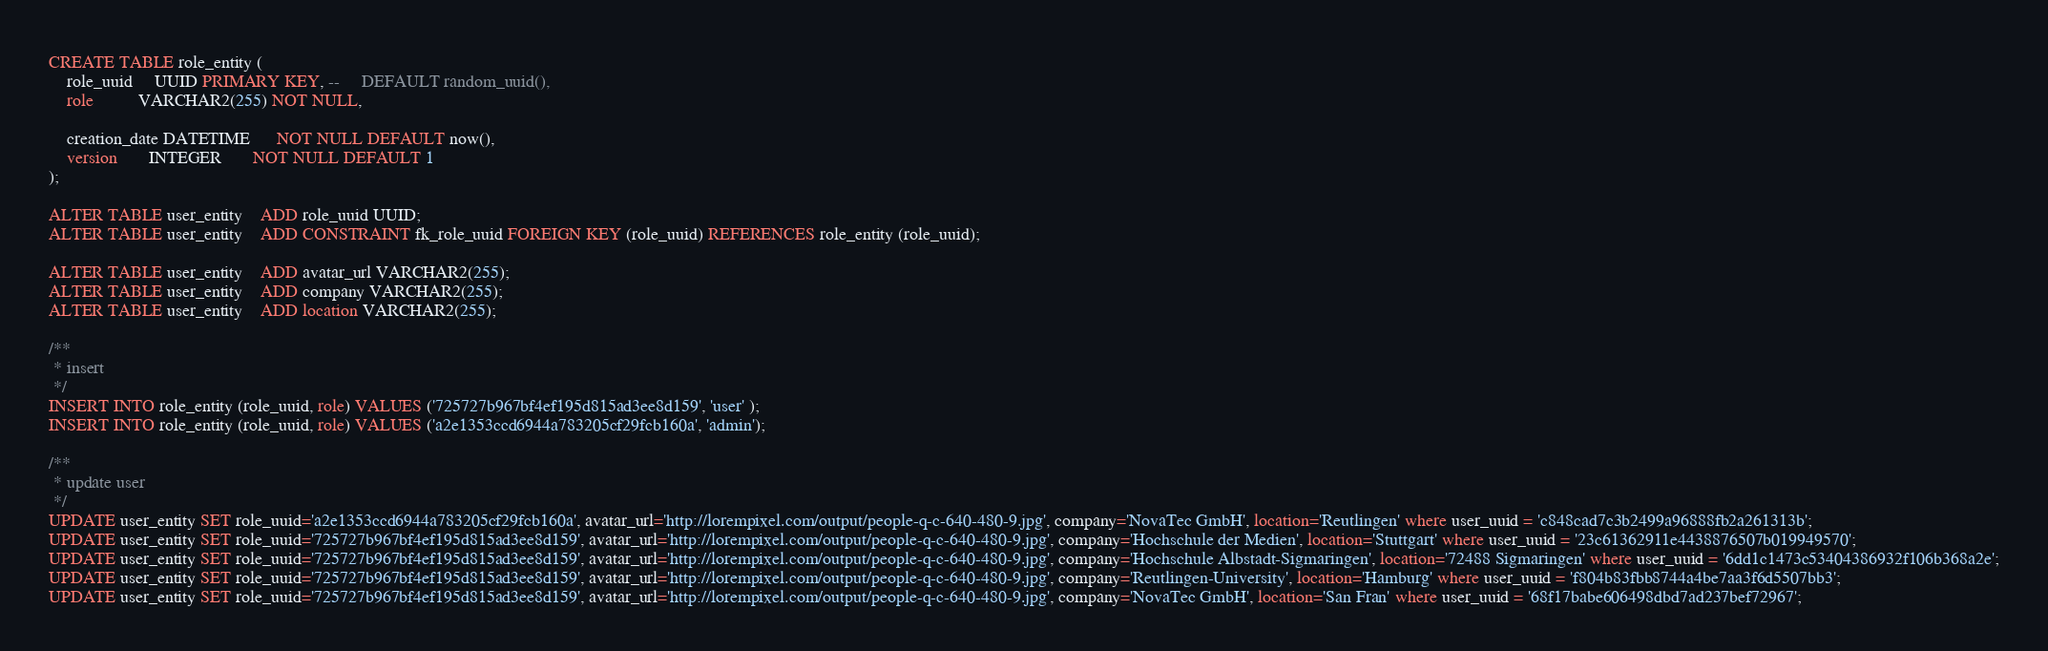<code> <loc_0><loc_0><loc_500><loc_500><_SQL_>CREATE TABLE role_entity (
	role_uuid     UUID PRIMARY KEY, --     DEFAULT random_uuid(),
	role          VARCHAR2(255) NOT NULL,

	creation_date DATETIME      NOT NULL DEFAULT now(),
	version       INTEGER       NOT NULL DEFAULT 1
);

ALTER TABLE user_entity	ADD role_uuid UUID;
ALTER TABLE user_entity	ADD CONSTRAINT fk_role_uuid FOREIGN KEY (role_uuid) REFERENCES role_entity (role_uuid);

ALTER TABLE user_entity	ADD avatar_url VARCHAR2(255);
ALTER TABLE user_entity	ADD company VARCHAR2(255);
ALTER TABLE user_entity	ADD location VARCHAR2(255);

/**
 * insert
 */
INSERT INTO role_entity (role_uuid, role) VALUES ('725727b967bf4ef195d815ad3ee8d159', 'user' );
INSERT INTO role_entity (role_uuid, role) VALUES ('a2e1353ccd6944a783205cf29fcb160a', 'admin');

/**
 * update user
 */
UPDATE user_entity SET role_uuid='a2e1353ccd6944a783205cf29fcb160a', avatar_url='http://lorempixel.com/output/people-q-c-640-480-9.jpg', company='NovaTec GmbH', location='Reutlingen' where user_uuid = 'c848cad7c3b2499a96888fb2a261313b';
UPDATE user_entity SET role_uuid='725727b967bf4ef195d815ad3ee8d159', avatar_url='http://lorempixel.com/output/people-q-c-640-480-9.jpg', company='Hochschule der Medien', location='Stuttgart' where user_uuid = '23c61362911e4438876507b019949570';
UPDATE user_entity SET role_uuid='725727b967bf4ef195d815ad3ee8d159', avatar_url='http://lorempixel.com/output/people-q-c-640-480-9.jpg', company='Hochschule Albstadt-Sigmaringen', location='72488 Sigmaringen' where user_uuid = '6dd1c1473c53404386932f106b368a2e';
UPDATE user_entity SET role_uuid='725727b967bf4ef195d815ad3ee8d159', avatar_url='http://lorempixel.com/output/people-q-c-640-480-9.jpg', company='Reutlingen-University', location='Hamburg' where user_uuid = 'f804b83fbb8744a4be7aa3f6d5507bb3';
UPDATE user_entity SET role_uuid='725727b967bf4ef195d815ad3ee8d159', avatar_url='http://lorempixel.com/output/people-q-c-640-480-9.jpg', company='NovaTec GmbH', location='San Fran' where user_uuid = '68f17babe606498dbd7ad237bef72967';

</code> 